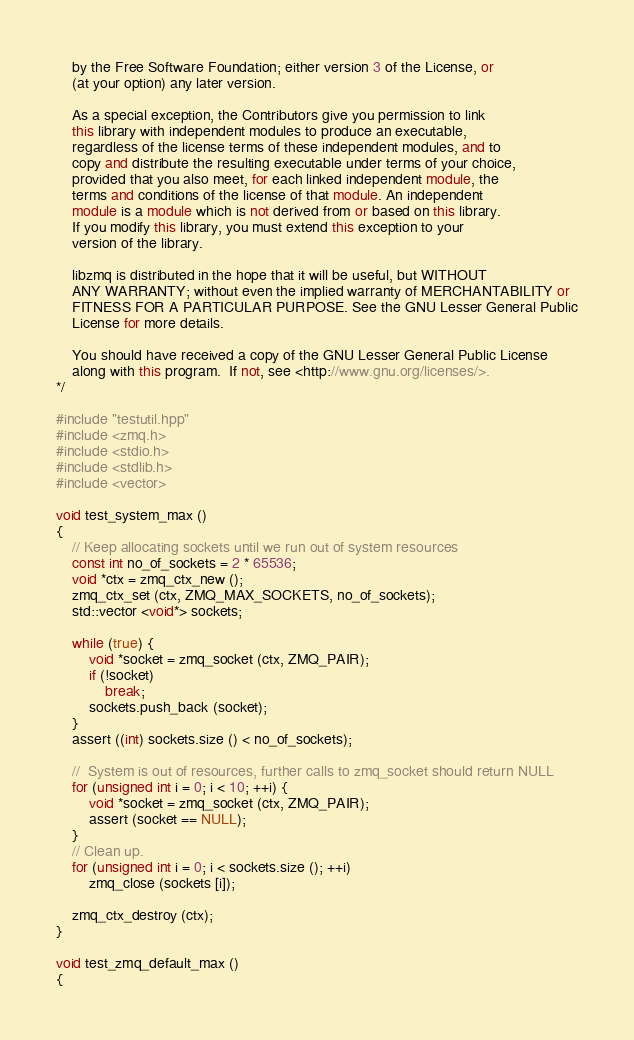<code> <loc_0><loc_0><loc_500><loc_500><_C++_>    by the Free Software Foundation; either version 3 of the License, or
    (at your option) any later version.

    As a special exception, the Contributors give you permission to link
    this library with independent modules to produce an executable,
    regardless of the license terms of these independent modules, and to
    copy and distribute the resulting executable under terms of your choice,
    provided that you also meet, for each linked independent module, the
    terms and conditions of the license of that module. An independent
    module is a module which is not derived from or based on this library.
    If you modify this library, you must extend this exception to your
    version of the library.

    libzmq is distributed in the hope that it will be useful, but WITHOUT
    ANY WARRANTY; without even the implied warranty of MERCHANTABILITY or
    FITNESS FOR A PARTICULAR PURPOSE. See the GNU Lesser General Public
    License for more details.

    You should have received a copy of the GNU Lesser General Public License
    along with this program.  If not, see <http://www.gnu.org/licenses/>.
*/

#include "testutil.hpp"
#include <zmq.h>
#include <stdio.h>
#include <stdlib.h>
#include <vector>

void test_system_max ()
{
    // Keep allocating sockets until we run out of system resources
    const int no_of_sockets = 2 * 65536;
    void *ctx = zmq_ctx_new ();
    zmq_ctx_set (ctx, ZMQ_MAX_SOCKETS, no_of_sockets);
    std::vector <void*> sockets;

    while (true) {
        void *socket = zmq_socket (ctx, ZMQ_PAIR);
        if (!socket)
            break;
        sockets.push_back (socket);
    }
    assert ((int) sockets.size () < no_of_sockets);

    //  System is out of resources, further calls to zmq_socket should return NULL
    for (unsigned int i = 0; i < 10; ++i) {
        void *socket = zmq_socket (ctx, ZMQ_PAIR);
        assert (socket == NULL);
    }
    // Clean up.
    for (unsigned int i = 0; i < sockets.size (); ++i)
        zmq_close (sockets [i]);

    zmq_ctx_destroy (ctx);
}

void test_zmq_default_max ()
{</code> 